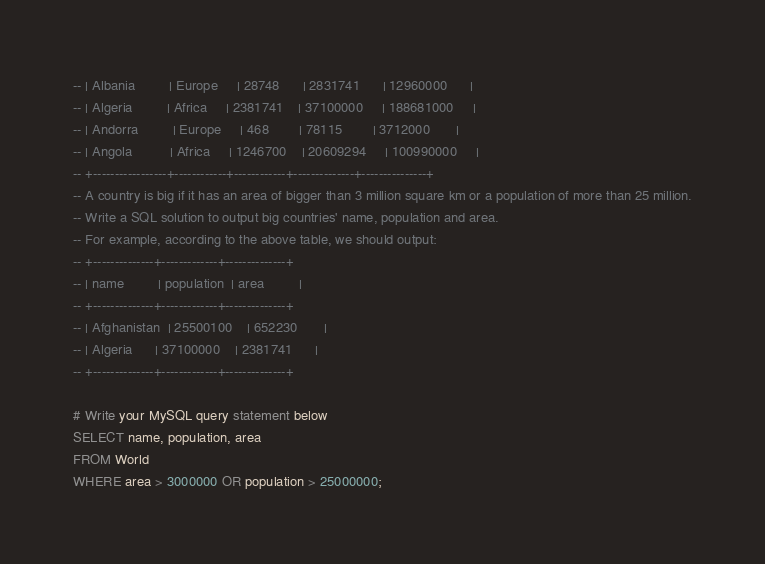Convert code to text. <code><loc_0><loc_0><loc_500><loc_500><_SQL_>-- | Albania         | Europe     | 28748      | 2831741      | 12960000      |
-- | Algeria         | Africa     | 2381741    | 37100000     | 188681000     |
-- | Andorra         | Europe     | 468        | 78115        | 3712000       |
-- | Angola          | Africa     | 1246700    | 20609294     | 100990000     |
-- +-----------------+------------+------------+--------------+---------------+
-- A country is big if it has an area of bigger than 3 million square km or a population of more than 25 million.
-- Write a SQL solution to output big countries' name, population and area.
-- For example, according to the above table, we should output:
-- +--------------+-------------+--------------+
-- | name         | population  | area         |
-- +--------------+-------------+--------------+
-- | Afghanistan  | 25500100    | 652230       |
-- | Algeria      | 37100000    | 2381741      |
-- +--------------+-------------+--------------+

# Write your MySQL query statement below
SELECT name, population, area
FROM World
WHERE area > 3000000 OR population > 25000000;</code> 